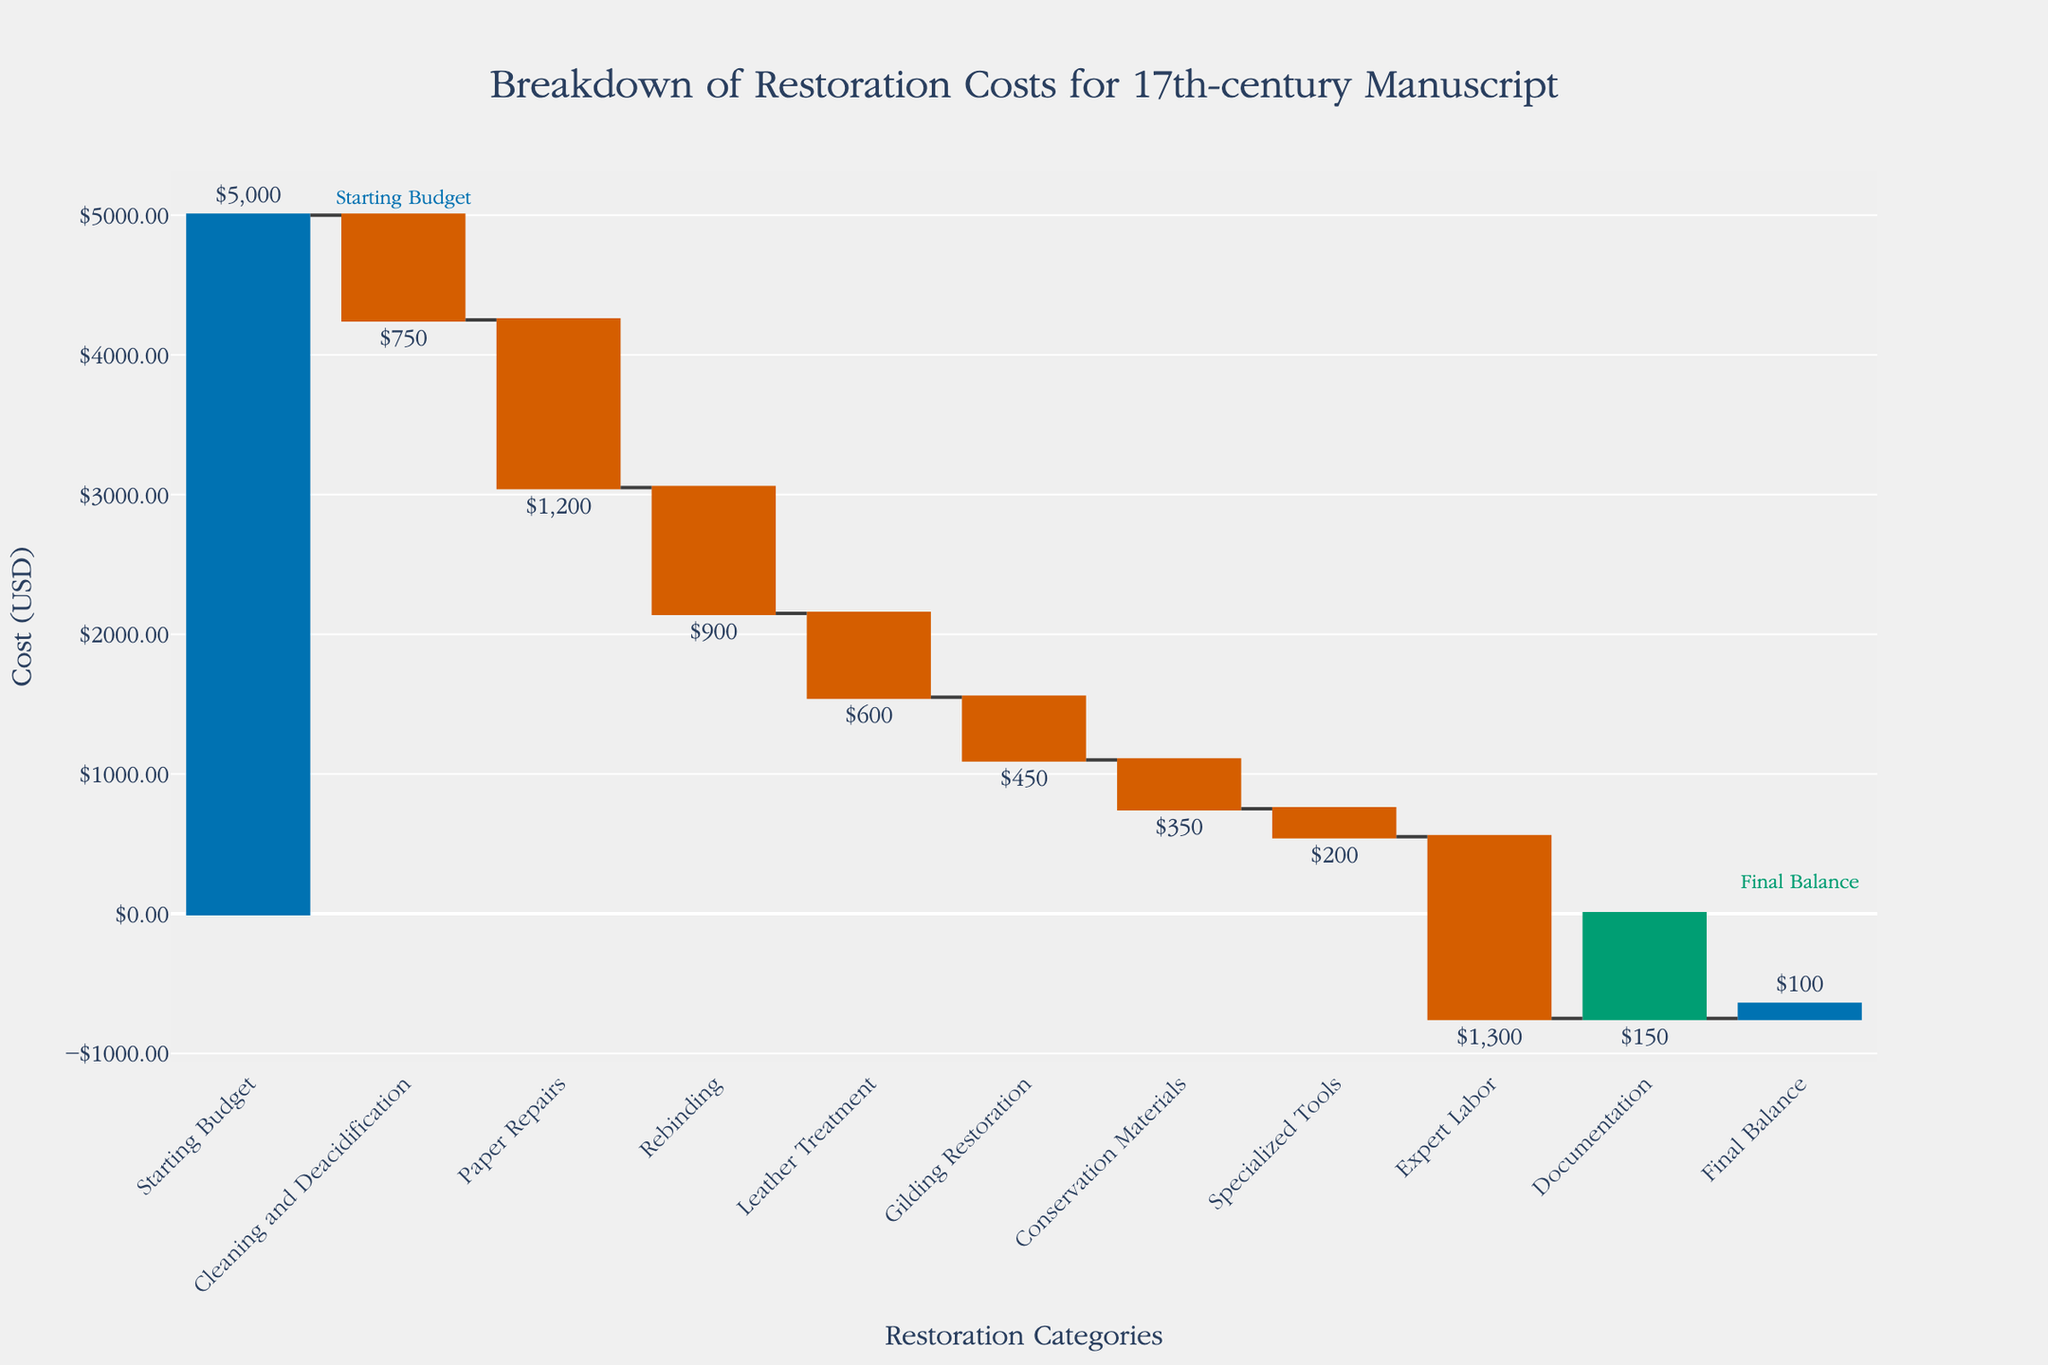What is the title of the chart? The title is usually found at the top of the chart, providing a general overview of what the chart depicts. Here, it is stated in the layout details of the code.
Answer: Breakdown of Restoration Costs for 17th-century Manuscript What is represented on the x-axis? The x-axis usually represents the different categories or phases involved in the chart. Here, it lists the restoration categories as per the provided data.
Answer: Restoration Categories What color represents the "Starting Budget" and "Final Balance"? The "Starting Budget" and "Final Balance" are marked differently for quick identification. Based on the color details given in the code, their colors can be observed in the visual representation.
Answer: "Starting Budget" is blue and "Final Balance" is green How much was spent on Expert Labor? "Expert Labor" is one of the categories on the x-axis, and its corresponding value can be identified by looking at the bars on the waterfall chart.
Answer: $1,300 What's the total spent on Cleaning and Deacidification and Paper Repairs combined? To find the total, locate and add the values corresponding to "Cleaning and Deacidification" and "Paper Repairs". From the data: -750 + -1200 = -1950.
Answer: $1,950 Compare the costs of Rebinding and Leather Treatment. Which one is higher? Identify the bars representing "Rebinding" and "Leather Treatment" and compare their values. Based on the data, Rebinding is -900, and Leather Treatment is -600.
Answer: Rebinding What is the final balance after all restoration expenses? The final balance can be identified from the "Final Balance" category in the chart. Based on the data, this is listed directly.
Answer: $100 What's the difference in cost between Gilding Restoration and Conservation Materials? Subtract the value of Conservation Materials from Gilding Restoration. From the data: -450 - (-350) = -450 + 350 = -100.
Answer: $100 Which restoration activity had the lowest cost? To find the lowest cost, compare all the categories' values. Based on the data values provided: Documentation is -150.
Answer: Documentation How much was spent in total on all activities excluding the final balance? Add up all the negative values to find the total expenses, not considering the final balance. Based on the data: -750 + -1200 + -900 + -600 + -450 + -350 + -200 + -1300 + -150 = -4900.
Answer: $4,900 